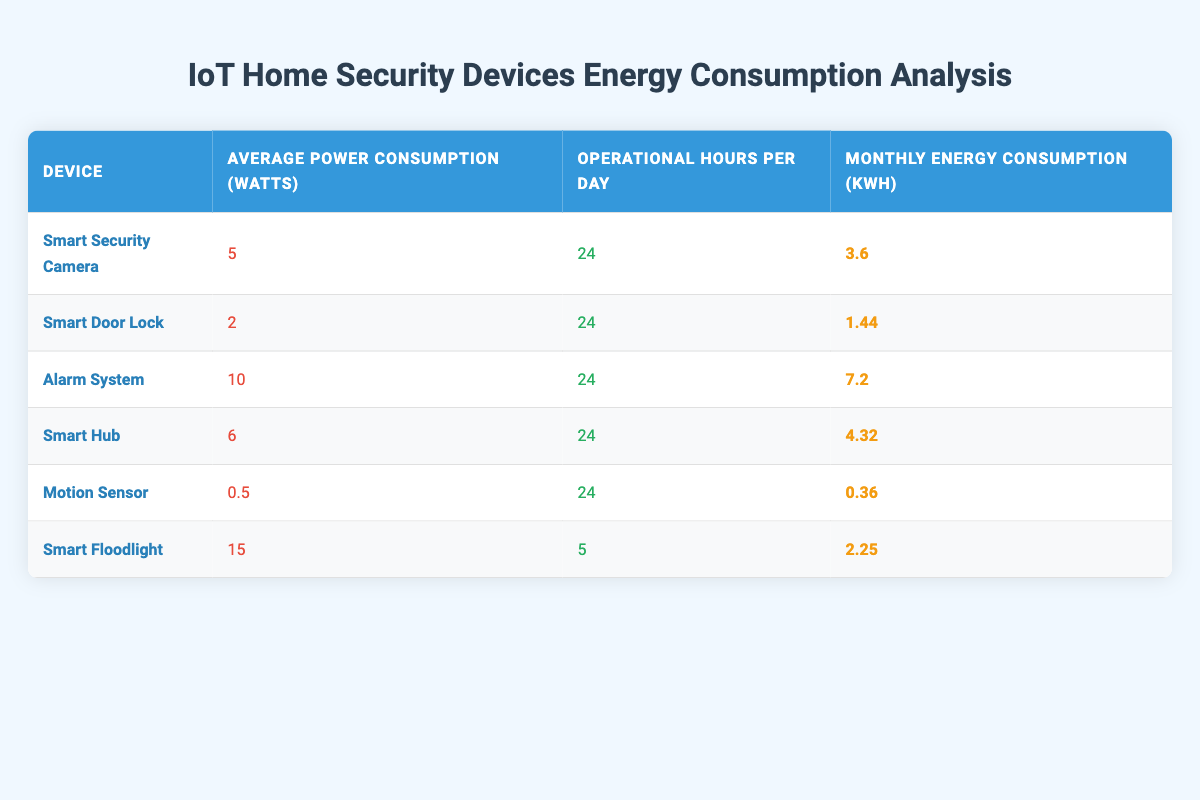What is the average power consumption of the Smart Door Lock? The table shows the average power consumption of the Smart Door Lock as 2 watts. Hence, the answer is directly obtained from the table.
Answer: 2 watts How many kWh does the Smart Floodlight consume monthly? According to the table, the monthly energy consumption of the Smart Floodlight is 2.25 kWh. The information is explicitly listed in the table for this device.
Answer: 2.25 kWh Which device has the highest monthly energy consumption? Analyzing the monthly energy consumption values in the table: Smart Security Camera (3.6), Smart Door Lock (1.44), Alarm System (7.2), Smart Hub (4.32), Motion Sensor (0.36), and Smart Floodlight (2.25). The Alarm System has the highest value at 7.2 kWh.
Answer: Alarm System If I sum the monthly energy consumption of all devices, what will be the total? To find the total, we add all the monthly energy consumptions listed: 3.6 + 1.44 + 7.2 + 4.32 + 0.36 + 2.25 = 19.17 kWh. This requires summing the relevant figures from each row in the table.
Answer: 19.17 kWh Is the average power consumption of the Motion Sensor less than that of the Smart Door Lock? The average power consumption of the Motion Sensor is 0.5 watts, while that of the Smart Door Lock is 2 watts. Since 0.5 is indeed less than 2, the statement is true.
Answer: Yes What is the combined power consumption of the Smart Security Camera and Smart Hub in watts? The Smart Security Camera consumes 5 watts and the Smart Hub consumes 6 watts. By adding these together, 5 + 6 = 11 watts provides the combined power consumption.
Answer: 11 watts Do any devices consume less than 1 watt on average? The table shows the Motion Sensor with an average power consumption of 0.5 watts. Since this is less than 1 watt, the answer is yes.
Answer: Yes What is the average monthly energy consumption across all devices? To find the average, first calculate the total monthly energy consumption (19.17 kWh) from earlier, then divide by the number of devices (6), which gives us 19.17 / 6 = 3.195 kWh. Therefore, the average monthly consumption is obtained by the sum divided by the count of devices.
Answer: 3.195 kWh 